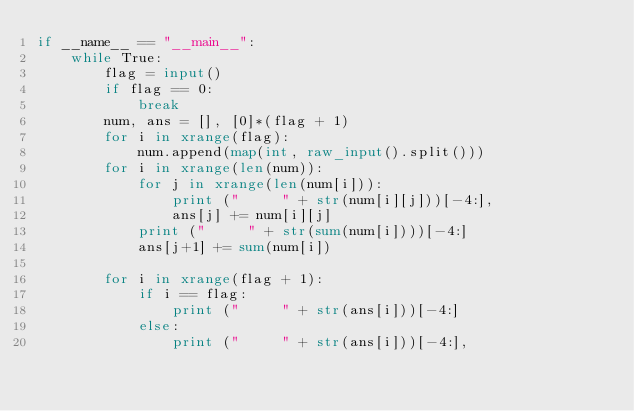<code> <loc_0><loc_0><loc_500><loc_500><_Python_>if __name__ == "__main__":
    while True:
        flag = input()
        if flag == 0:
            break
        num, ans = [], [0]*(flag + 1)
        for i in xrange(flag):
            num.append(map(int, raw_input().split()))
        for i in xrange(len(num)):
            for j in xrange(len(num[i])):
                print ("     " + str(num[i][j]))[-4:],
                ans[j] += num[i][j]
            print ("     " + str(sum(num[i])))[-4:]
            ans[j+1] += sum(num[i])

        for i in xrange(flag + 1):
            if i == flag:
                print ("     " + str(ans[i]))[-4:]
            else:
                print ("     " + str(ans[i]))[-4:],</code> 